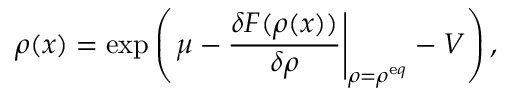Convert formula to latex. <formula><loc_0><loc_0><loc_500><loc_500>\rho ( x ) = \exp \left ( \mu - \frac { \delta F ( \rho ( x ) ) } { \delta \rho } \right | _ { \rho = \rho ^ { \mathrm e q } } - V \right ) ,</formula> 